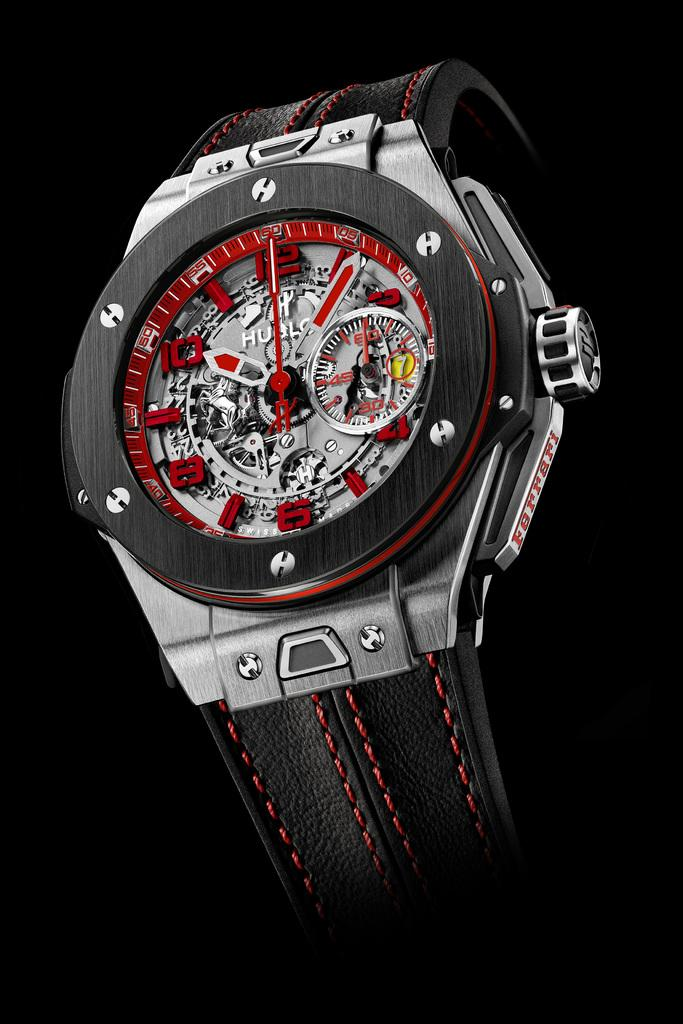Provide a one-sentence caption for the provided image. A watch has the brand name Ferrari on the outer edge. 